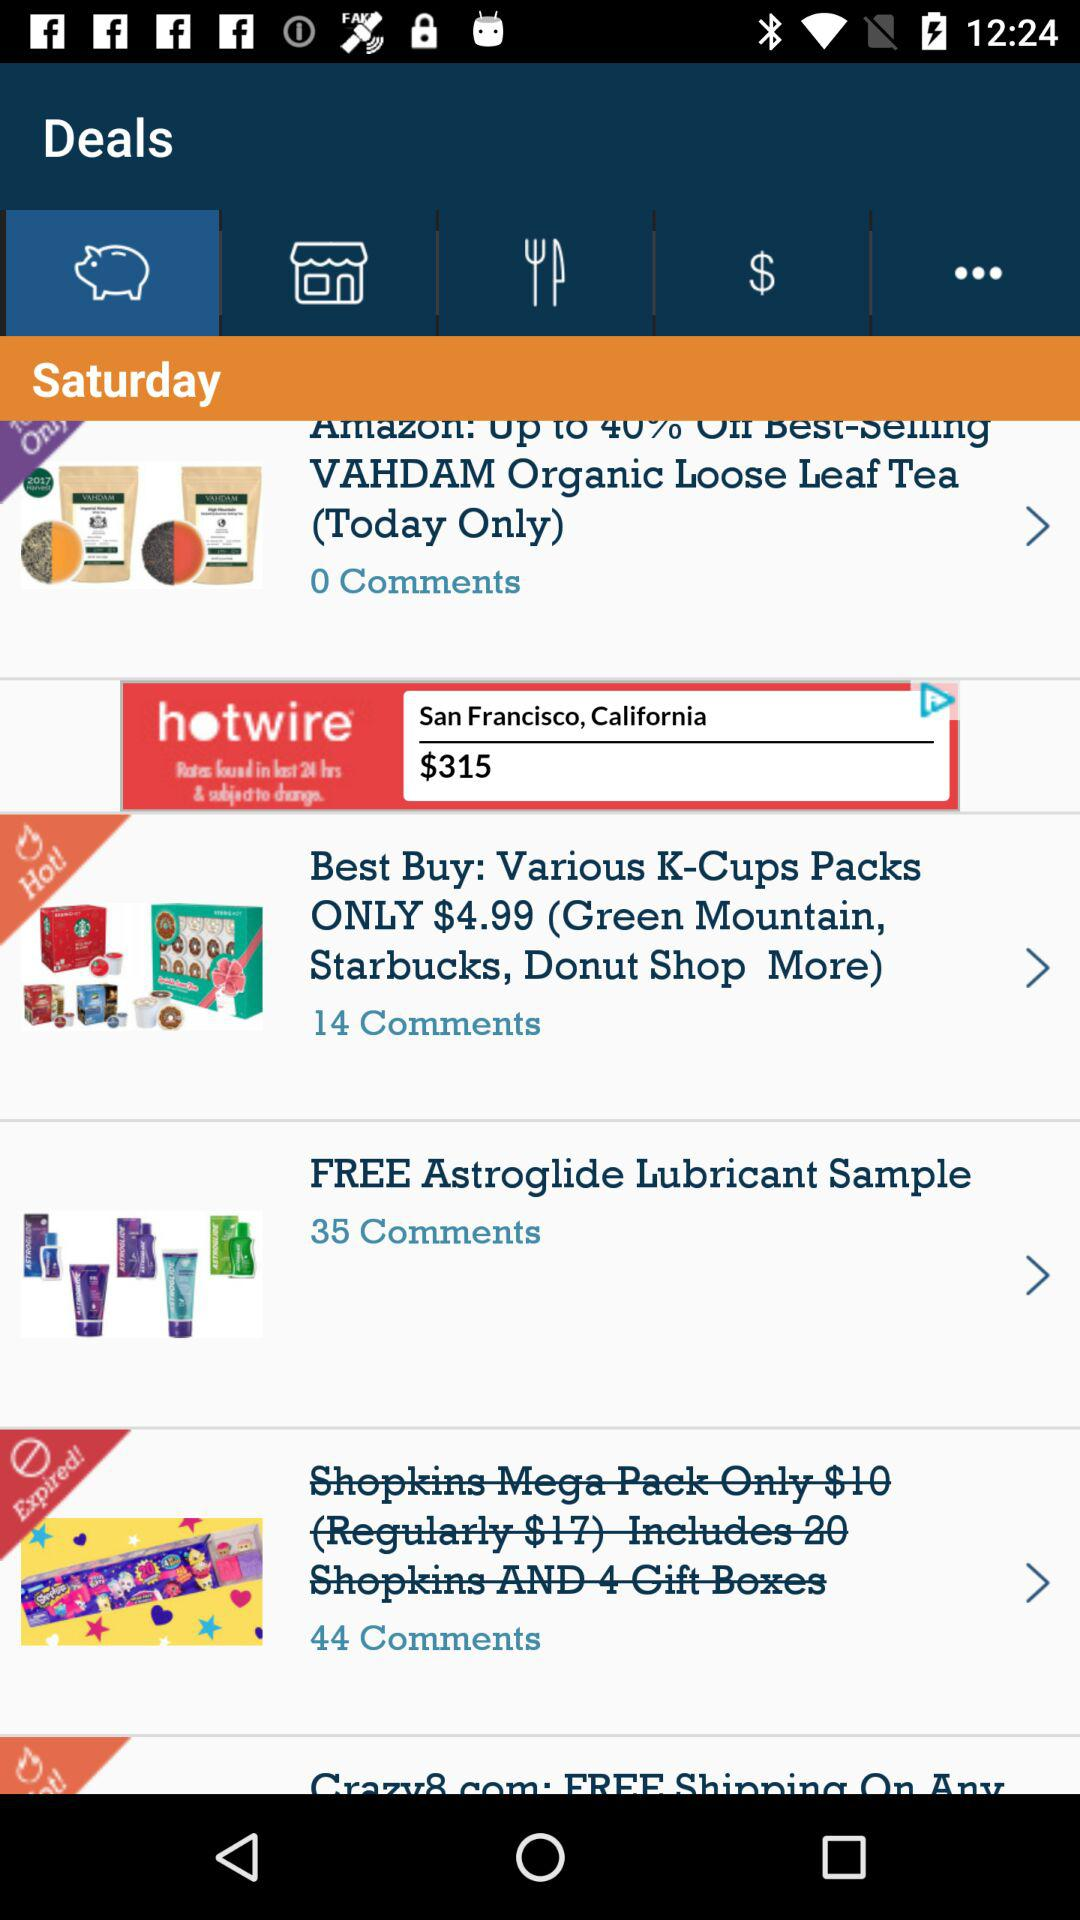How many comments on the K-Cups packs are there? There are 14 comments. 